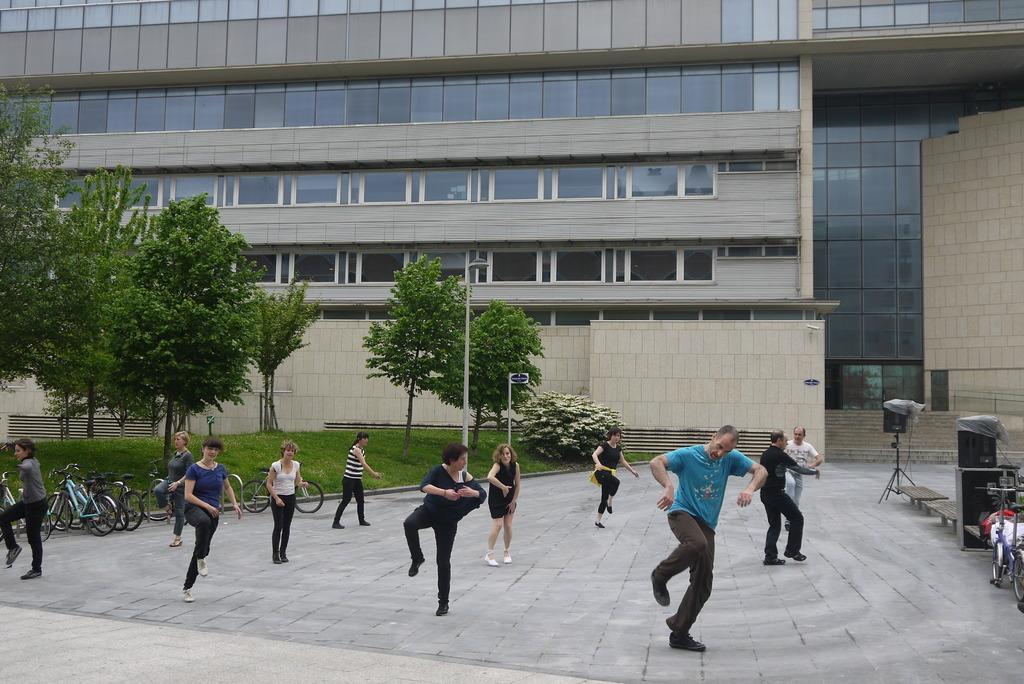Describe this image in one or two sentences. In the background we can see a building, stairs. In this picture we can see the trees, grass, board, light, poles. We can see the bicycles and few objects. We can see the people and they are dancing. 